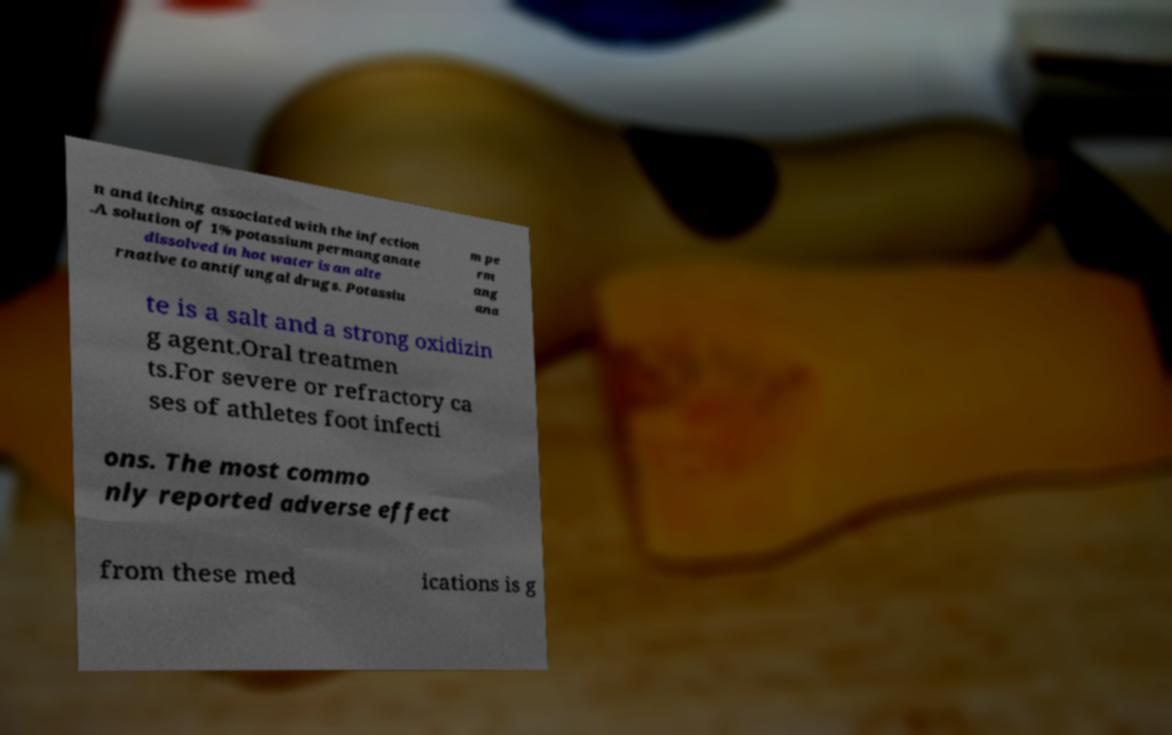For documentation purposes, I need the text within this image transcribed. Could you provide that? n and itching associated with the infection .A solution of 1% potassium permanganate dissolved in hot water is an alte rnative to antifungal drugs. Potassiu m pe rm ang ana te is a salt and a strong oxidizin g agent.Oral treatmen ts.For severe or refractory ca ses of athletes foot infecti ons. The most commo nly reported adverse effect from these med ications is g 